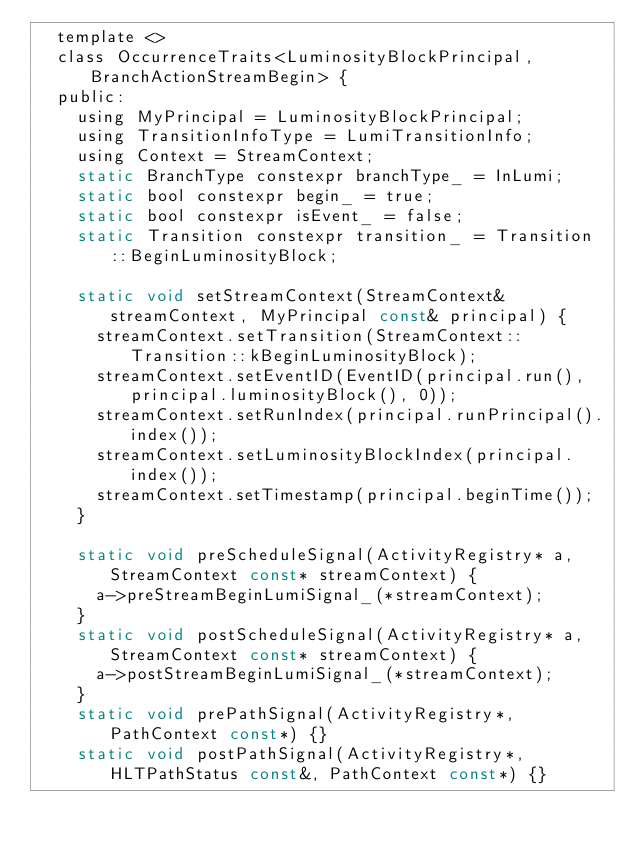<code> <loc_0><loc_0><loc_500><loc_500><_C_>  template <>
  class OccurrenceTraits<LuminosityBlockPrincipal, BranchActionStreamBegin> {
  public:
    using MyPrincipal = LuminosityBlockPrincipal;
    using TransitionInfoType = LumiTransitionInfo;
    using Context = StreamContext;
    static BranchType constexpr branchType_ = InLumi;
    static bool constexpr begin_ = true;
    static bool constexpr isEvent_ = false;
    static Transition constexpr transition_ = Transition::BeginLuminosityBlock;

    static void setStreamContext(StreamContext& streamContext, MyPrincipal const& principal) {
      streamContext.setTransition(StreamContext::Transition::kBeginLuminosityBlock);
      streamContext.setEventID(EventID(principal.run(), principal.luminosityBlock(), 0));
      streamContext.setRunIndex(principal.runPrincipal().index());
      streamContext.setLuminosityBlockIndex(principal.index());
      streamContext.setTimestamp(principal.beginTime());
    }

    static void preScheduleSignal(ActivityRegistry* a, StreamContext const* streamContext) {
      a->preStreamBeginLumiSignal_(*streamContext);
    }
    static void postScheduleSignal(ActivityRegistry* a, StreamContext const* streamContext) {
      a->postStreamBeginLumiSignal_(*streamContext);
    }
    static void prePathSignal(ActivityRegistry*, PathContext const*) {}
    static void postPathSignal(ActivityRegistry*, HLTPathStatus const&, PathContext const*) {}</code> 